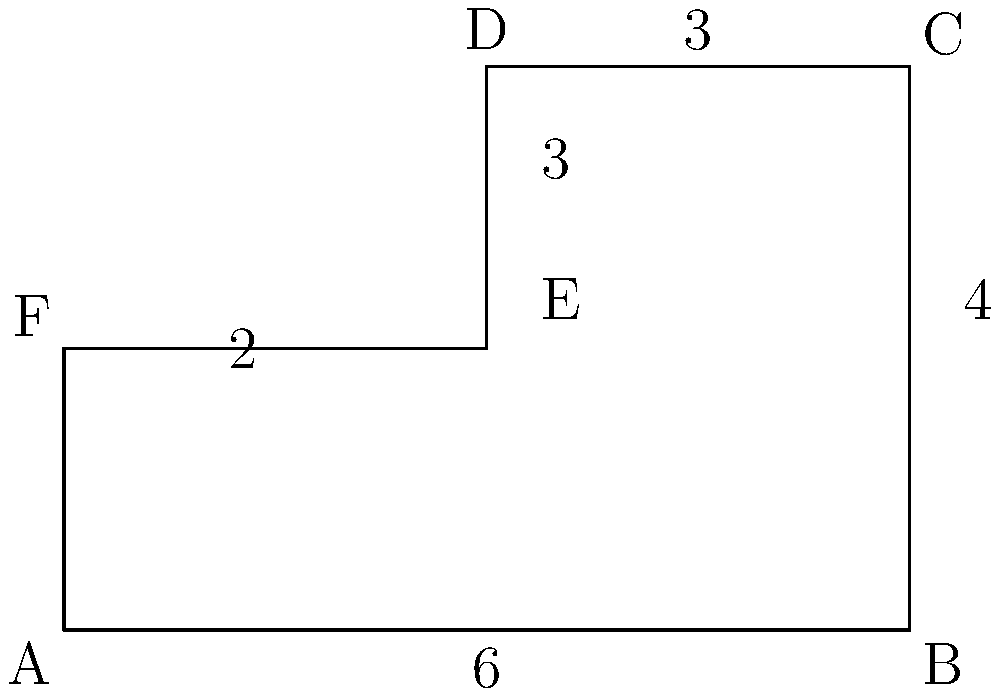As an app developer concerned about licensing and cracking issues, you're designing a shape-based encryption algorithm. The algorithm uses the perimeter of composite shapes as a key component. Given the composite shape above, where all angles are right angles and dimensions are in arbitrary units, calculate the perimeter. This will help ensure the security of your app's licensing system. To find the perimeter of this composite shape, we need to sum up the lengths of all outer edges. Let's break it down step by step:

1) First, let's identify the outer edges:
   - Bottom edge: $AB = 6$ units
   - Right edge: $BC = 4$ units
   - Top edge: $CD + DE + EF = 3 + 3 + 3 = 9$ units
   - Left edge: $FA = 2$ units

2) Now, let's sum up these lengths:
   $\text{Perimeter} = AB + BC + CD + DE + EF + FA$
   $= 6 + 4 + 3 + 3 + 3 + 2$
   $= 21$ units

Therefore, the perimeter of the composite shape is 21 units.

This value could be used as part of your encryption key in the licensing system, making it harder for potential crackers to reverse-engineer your app's protection mechanism.
Answer: 21 units 